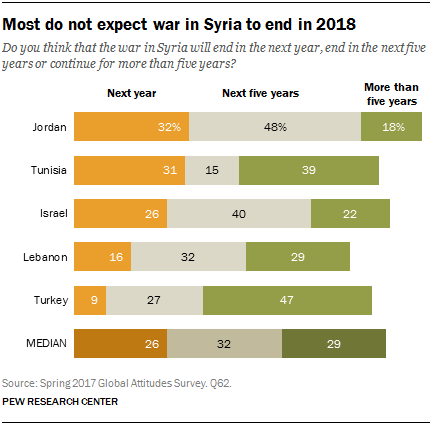Highlight a few significant elements in this photo. There are three colors on the bar. There will be a stark contrast between Israel and Lebanon next year, with 10% of the Lebanese population expected to fall into poverty, while the Israeli economy is projected to grow by 3.5%. 